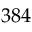<formula> <loc_0><loc_0><loc_500><loc_500>3 8 4</formula> 